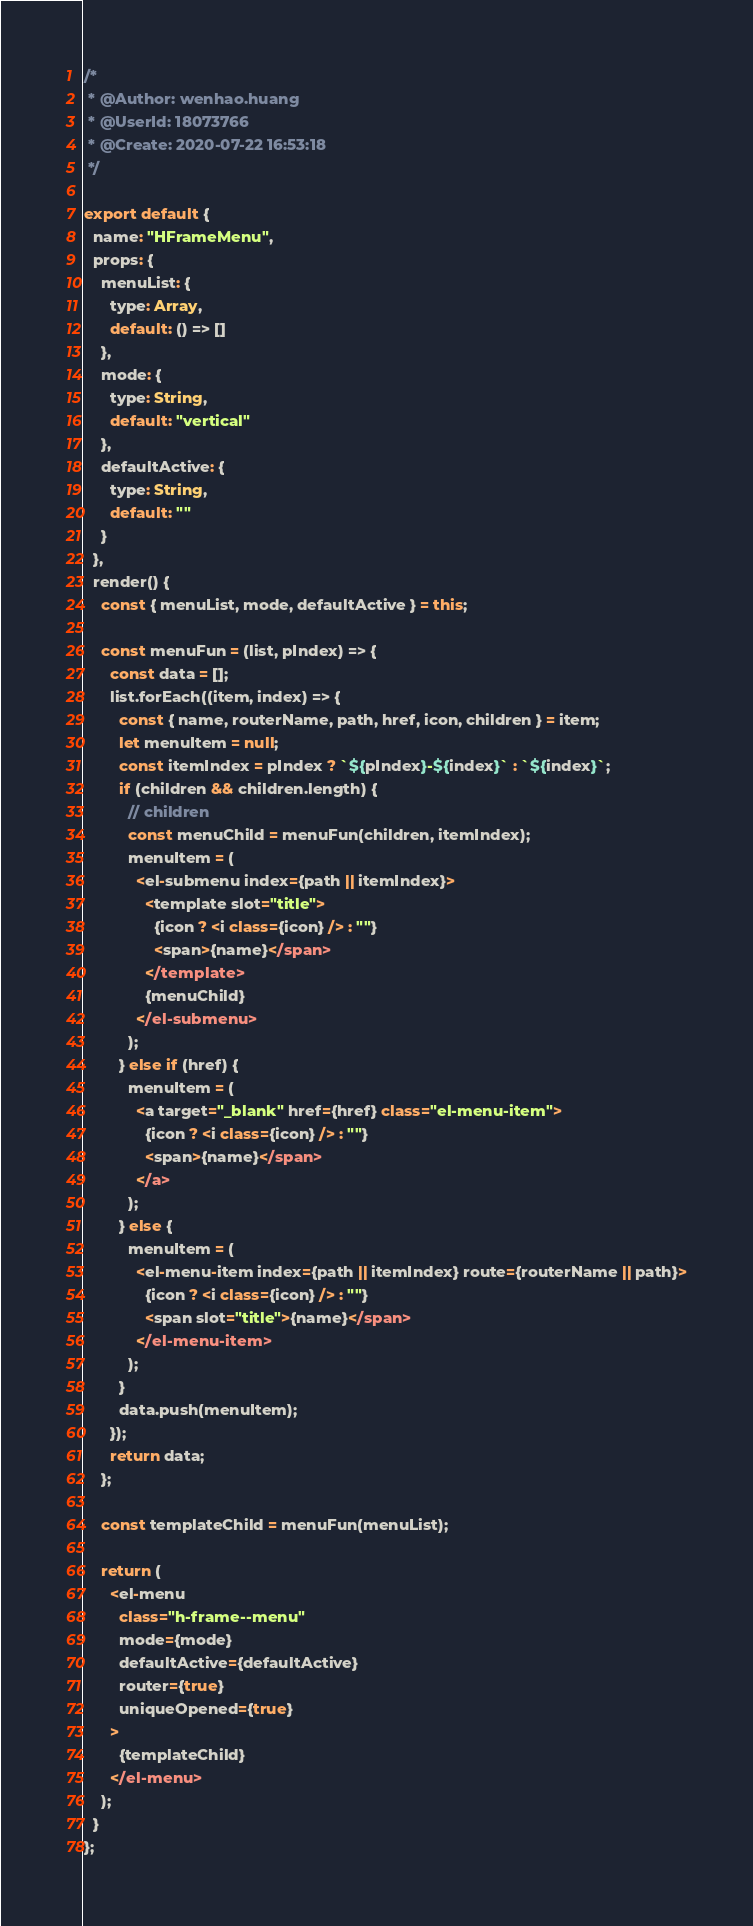<code> <loc_0><loc_0><loc_500><loc_500><_JavaScript_>/*
 * @Author: wenhao.huang
 * @UserId: 18073766
 * @Create: 2020-07-22 16:53:18
 */

export default {
  name: "HFrameMenu",
  props: {
    menuList: {
      type: Array,
      default: () => []
    },
    mode: {
      type: String,
      default: "vertical"
    },
    defaultActive: {
      type: String,
      default: ""
    }
  },
  render() {
    const { menuList, mode, defaultActive } = this;

    const menuFun = (list, pIndex) => {
      const data = [];
      list.forEach((item, index) => {
        const { name, routerName, path, href, icon, children } = item;
        let menuItem = null;
        const itemIndex = pIndex ? `${pIndex}-${index}` : `${index}`;
        if (children && children.length) {
          // children
          const menuChild = menuFun(children, itemIndex);
          menuItem = (
            <el-submenu index={path || itemIndex}>
              <template slot="title">
                {icon ? <i class={icon} /> : ""}
                <span>{name}</span>
              </template>
              {menuChild}
            </el-submenu>
          );
        } else if (href) {
          menuItem = (
            <a target="_blank" href={href} class="el-menu-item">
              {icon ? <i class={icon} /> : ""}
              <span>{name}</span>
            </a>
          );
        } else {
          menuItem = (
            <el-menu-item index={path || itemIndex} route={routerName || path}>
              {icon ? <i class={icon} /> : ""}
              <span slot="title">{name}</span>
            </el-menu-item>
          );
        }
        data.push(menuItem);
      });
      return data;
    };

    const templateChild = menuFun(menuList);

    return (
      <el-menu
        class="h-frame--menu"
        mode={mode}
        defaultActive={defaultActive}
        router={true}
        uniqueOpened={true}
      >
        {templateChild}
      </el-menu>
    );
  }
};
</code> 